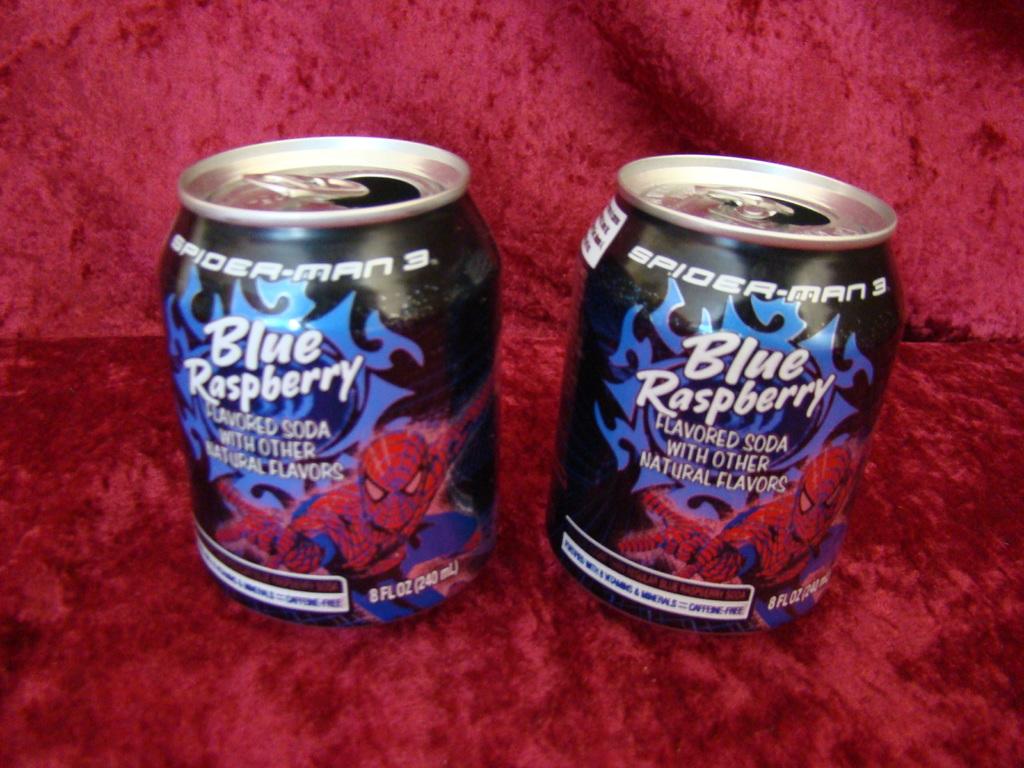What flavor of soda is in the can?
Your response must be concise. Blue raspberry. What movie is being promoted on the can?
Offer a terse response. Spider-man 3. 